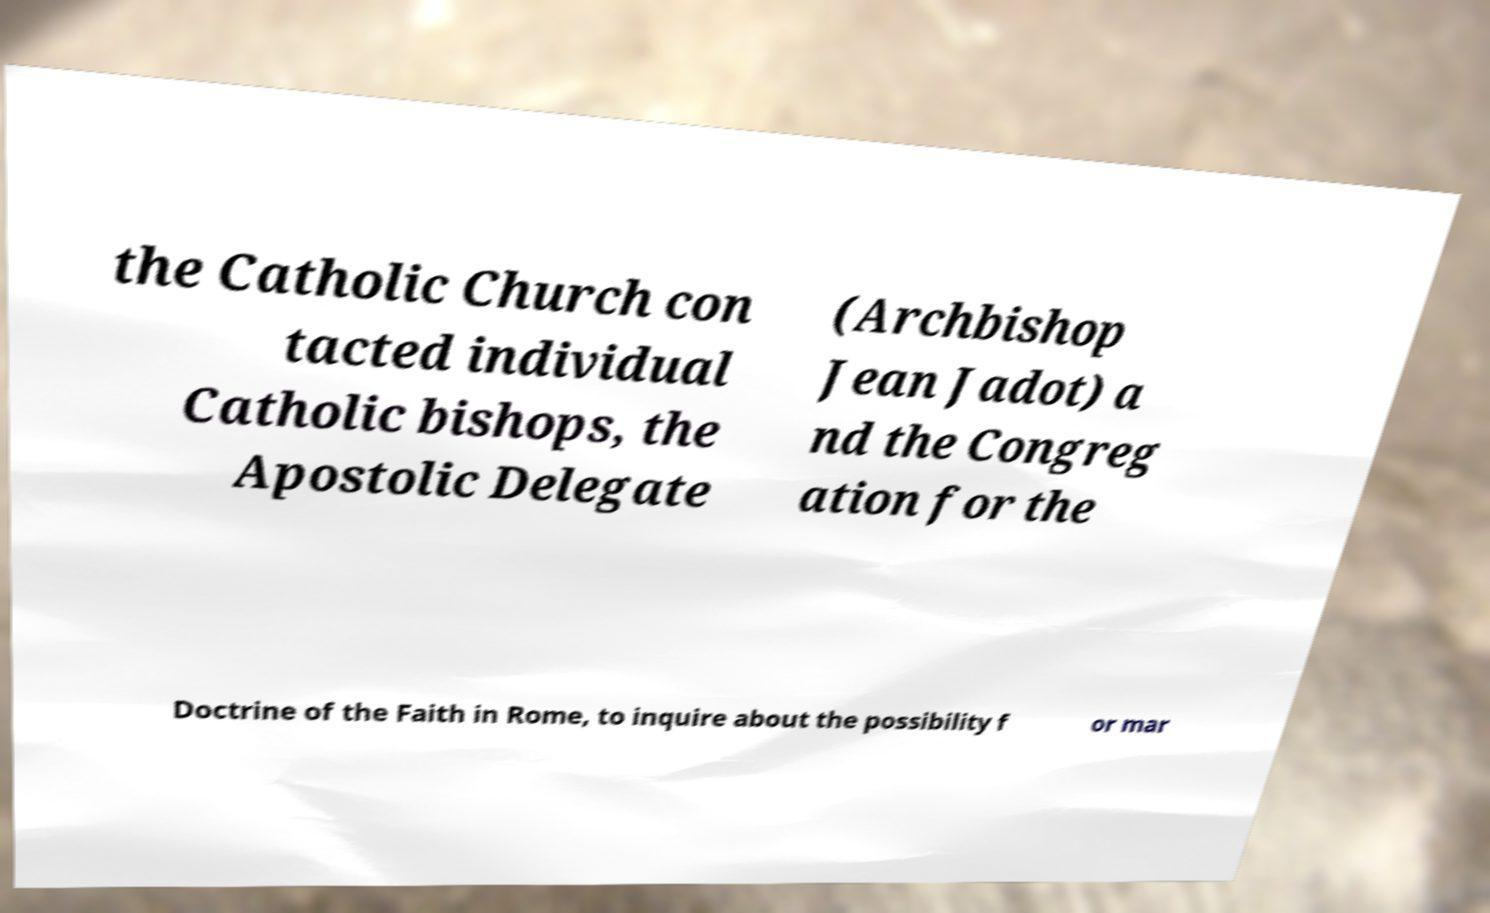I need the written content from this picture converted into text. Can you do that? the Catholic Church con tacted individual Catholic bishops, the Apostolic Delegate (Archbishop Jean Jadot) a nd the Congreg ation for the Doctrine of the Faith in Rome, to inquire about the possibility f or mar 